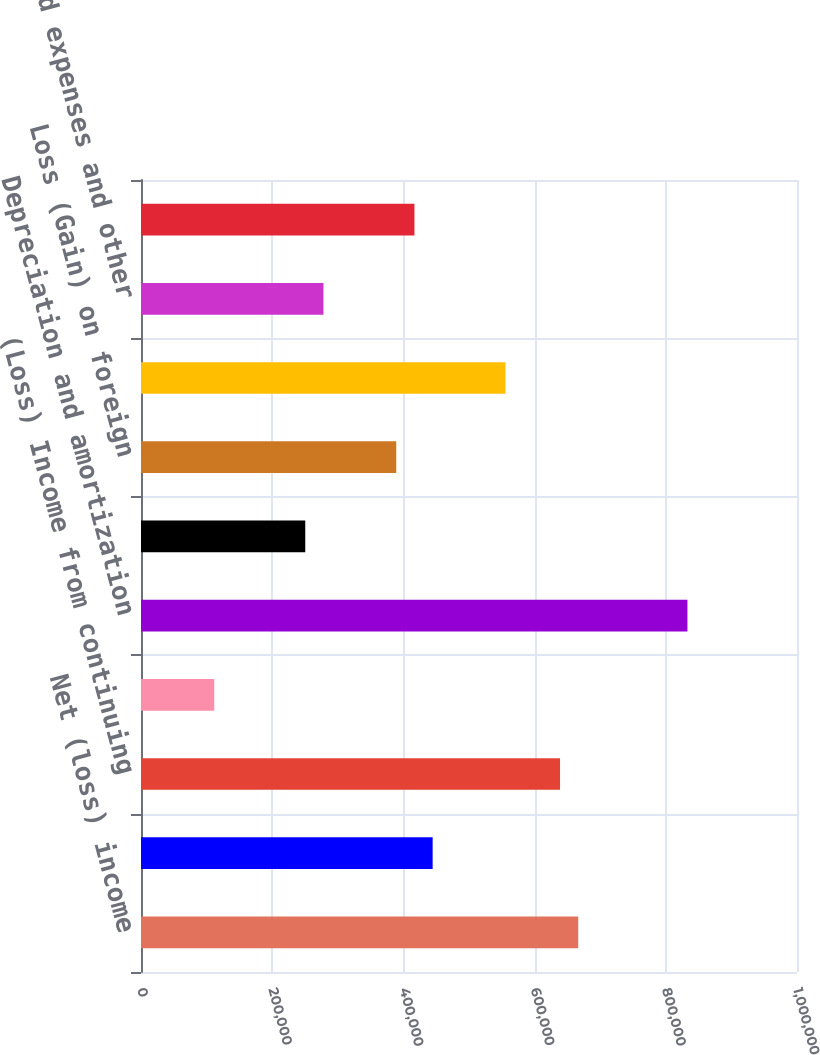Convert chart to OTSL. <chart><loc_0><loc_0><loc_500><loc_500><bar_chart><fcel>Net (loss) income<fcel>Extraordinary charges from<fcel>(Loss) Income from continuing<fcel>Minority interests<fcel>Depreciation and amortization<fcel>Amortization of deferred<fcel>Loss (Gain) on foreign<fcel>Accounts receivable<fcel>Prepaid expenses and other<fcel>Deferred income taxes<nl><fcel>666518<fcel>444586<fcel>638777<fcel>111686<fcel>832968<fcel>250394<fcel>389102<fcel>555552<fcel>278136<fcel>416844<nl></chart> 